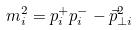Convert formula to latex. <formula><loc_0><loc_0><loc_500><loc_500>m _ { i } ^ { 2 } = p _ { i } ^ { + } p _ { i } ^ { - } - \vec { p } _ { \perp i } ^ { 2 }</formula> 